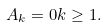<formula> <loc_0><loc_0><loc_500><loc_500>A _ { k } = 0 k \geq 1 .</formula> 